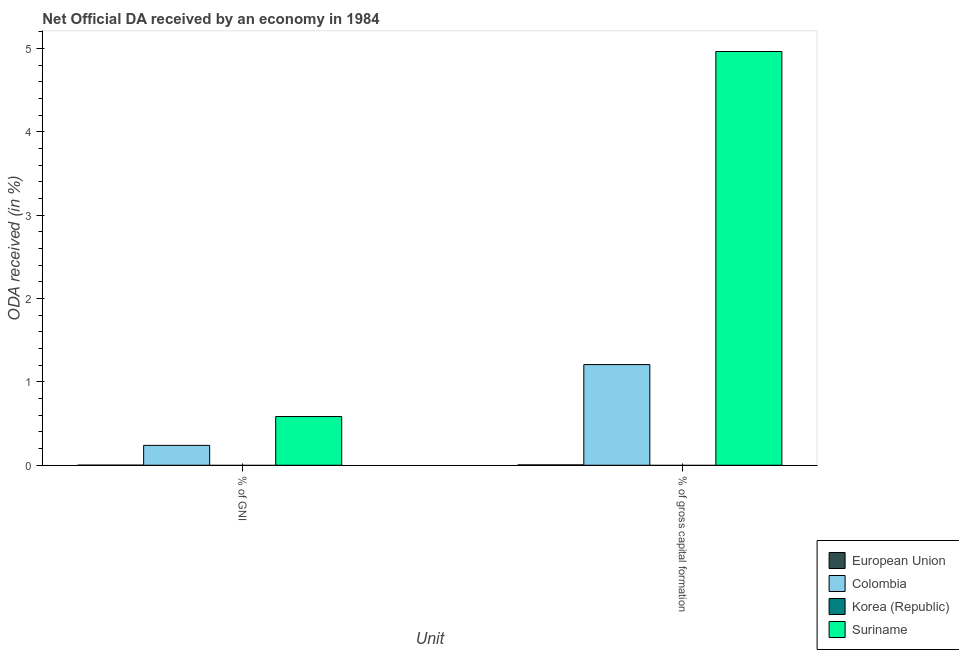How many different coloured bars are there?
Your response must be concise. 3. How many groups of bars are there?
Keep it short and to the point. 2. Are the number of bars per tick equal to the number of legend labels?
Provide a succinct answer. No. Are the number of bars on each tick of the X-axis equal?
Provide a succinct answer. Yes. How many bars are there on the 1st tick from the right?
Your response must be concise. 3. What is the label of the 2nd group of bars from the left?
Make the answer very short. % of gross capital formation. What is the oda received as percentage of gross capital formation in Colombia?
Offer a terse response. 1.21. Across all countries, what is the maximum oda received as percentage of gross capital formation?
Offer a terse response. 4.97. Across all countries, what is the minimum oda received as percentage of gross capital formation?
Offer a terse response. 0. In which country was the oda received as percentage of gni maximum?
Ensure brevity in your answer.  Suriname. What is the total oda received as percentage of gross capital formation in the graph?
Offer a terse response. 6.18. What is the difference between the oda received as percentage of gni in Colombia and that in European Union?
Offer a very short reply. 0.24. What is the difference between the oda received as percentage of gni in Colombia and the oda received as percentage of gross capital formation in Suriname?
Provide a short and direct response. -4.73. What is the average oda received as percentage of gni per country?
Your answer should be compact. 0.21. What is the difference between the oda received as percentage of gross capital formation and oda received as percentage of gni in Colombia?
Give a very brief answer. 0.97. In how many countries, is the oda received as percentage of gni greater than 2 %?
Make the answer very short. 0. What is the ratio of the oda received as percentage of gross capital formation in Suriname to that in Colombia?
Ensure brevity in your answer.  4.11. Is the oda received as percentage of gni in Colombia less than that in Suriname?
Give a very brief answer. Yes. In how many countries, is the oda received as percentage of gross capital formation greater than the average oda received as percentage of gross capital formation taken over all countries?
Provide a short and direct response. 1. Are all the bars in the graph horizontal?
Your response must be concise. No. How many countries are there in the graph?
Provide a succinct answer. 4. Does the graph contain any zero values?
Provide a succinct answer. Yes. Does the graph contain grids?
Give a very brief answer. No. What is the title of the graph?
Your response must be concise. Net Official DA received by an economy in 1984. What is the label or title of the X-axis?
Provide a succinct answer. Unit. What is the label or title of the Y-axis?
Ensure brevity in your answer.  ODA received (in %). What is the ODA received (in %) of European Union in % of GNI?
Your answer should be very brief. 0. What is the ODA received (in %) in Colombia in % of GNI?
Provide a short and direct response. 0.24. What is the ODA received (in %) of Korea (Republic) in % of GNI?
Give a very brief answer. 0. What is the ODA received (in %) of Suriname in % of GNI?
Ensure brevity in your answer.  0.58. What is the ODA received (in %) of European Union in % of gross capital formation?
Provide a succinct answer. 0. What is the ODA received (in %) in Colombia in % of gross capital formation?
Your response must be concise. 1.21. What is the ODA received (in %) in Korea (Republic) in % of gross capital formation?
Provide a succinct answer. 0. What is the ODA received (in %) of Suriname in % of gross capital formation?
Offer a terse response. 4.97. Across all Unit, what is the maximum ODA received (in %) of European Union?
Make the answer very short. 0. Across all Unit, what is the maximum ODA received (in %) of Colombia?
Keep it short and to the point. 1.21. Across all Unit, what is the maximum ODA received (in %) of Suriname?
Keep it short and to the point. 4.97. Across all Unit, what is the minimum ODA received (in %) in European Union?
Keep it short and to the point. 0. Across all Unit, what is the minimum ODA received (in %) of Colombia?
Provide a succinct answer. 0.24. Across all Unit, what is the minimum ODA received (in %) of Suriname?
Make the answer very short. 0.58. What is the total ODA received (in %) of European Union in the graph?
Your answer should be compact. 0.01. What is the total ODA received (in %) of Colombia in the graph?
Offer a very short reply. 1.45. What is the total ODA received (in %) in Suriname in the graph?
Provide a succinct answer. 5.55. What is the difference between the ODA received (in %) in European Union in % of GNI and that in % of gross capital formation?
Offer a terse response. -0. What is the difference between the ODA received (in %) of Colombia in % of GNI and that in % of gross capital formation?
Your answer should be very brief. -0.97. What is the difference between the ODA received (in %) of Suriname in % of GNI and that in % of gross capital formation?
Offer a very short reply. -4.38. What is the difference between the ODA received (in %) in European Union in % of GNI and the ODA received (in %) in Colombia in % of gross capital formation?
Your answer should be compact. -1.21. What is the difference between the ODA received (in %) in European Union in % of GNI and the ODA received (in %) in Suriname in % of gross capital formation?
Your answer should be very brief. -4.96. What is the difference between the ODA received (in %) in Colombia in % of GNI and the ODA received (in %) in Suriname in % of gross capital formation?
Your answer should be very brief. -4.73. What is the average ODA received (in %) of European Union per Unit?
Provide a succinct answer. 0. What is the average ODA received (in %) of Colombia per Unit?
Your response must be concise. 0.72. What is the average ODA received (in %) in Korea (Republic) per Unit?
Give a very brief answer. 0. What is the average ODA received (in %) of Suriname per Unit?
Offer a terse response. 2.78. What is the difference between the ODA received (in %) in European Union and ODA received (in %) in Colombia in % of GNI?
Ensure brevity in your answer.  -0.24. What is the difference between the ODA received (in %) in European Union and ODA received (in %) in Suriname in % of GNI?
Ensure brevity in your answer.  -0.58. What is the difference between the ODA received (in %) in Colombia and ODA received (in %) in Suriname in % of GNI?
Make the answer very short. -0.35. What is the difference between the ODA received (in %) in European Union and ODA received (in %) in Colombia in % of gross capital formation?
Keep it short and to the point. -1.2. What is the difference between the ODA received (in %) in European Union and ODA received (in %) in Suriname in % of gross capital formation?
Provide a short and direct response. -4.96. What is the difference between the ODA received (in %) in Colombia and ODA received (in %) in Suriname in % of gross capital formation?
Offer a very short reply. -3.76. What is the ratio of the ODA received (in %) of European Union in % of GNI to that in % of gross capital formation?
Your response must be concise. 0.22. What is the ratio of the ODA received (in %) in Colombia in % of GNI to that in % of gross capital formation?
Keep it short and to the point. 0.2. What is the ratio of the ODA received (in %) in Suriname in % of GNI to that in % of gross capital formation?
Give a very brief answer. 0.12. What is the difference between the highest and the second highest ODA received (in %) of European Union?
Your answer should be very brief. 0. What is the difference between the highest and the second highest ODA received (in %) of Colombia?
Provide a succinct answer. 0.97. What is the difference between the highest and the second highest ODA received (in %) in Suriname?
Offer a very short reply. 4.38. What is the difference between the highest and the lowest ODA received (in %) of European Union?
Provide a succinct answer. 0. What is the difference between the highest and the lowest ODA received (in %) of Colombia?
Keep it short and to the point. 0.97. What is the difference between the highest and the lowest ODA received (in %) of Suriname?
Offer a very short reply. 4.38. 